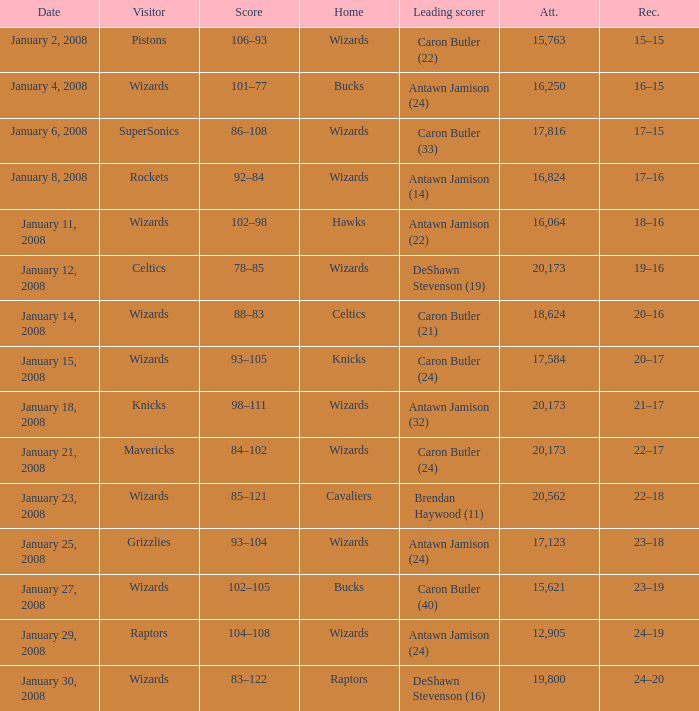Would you be able to parse every entry in this table? {'header': ['Date', 'Visitor', 'Score', 'Home', 'Leading scorer', 'Att.', 'Rec.'], 'rows': [['January 2, 2008', 'Pistons', '106–93', 'Wizards', 'Caron Butler (22)', '15,763', '15–15'], ['January 4, 2008', 'Wizards', '101–77', 'Bucks', 'Antawn Jamison (24)', '16,250', '16–15'], ['January 6, 2008', 'SuperSonics', '86–108', 'Wizards', 'Caron Butler (33)', '17,816', '17–15'], ['January 8, 2008', 'Rockets', '92–84', 'Wizards', 'Antawn Jamison (14)', '16,824', '17–16'], ['January 11, 2008', 'Wizards', '102–98', 'Hawks', 'Antawn Jamison (22)', '16,064', '18–16'], ['January 12, 2008', 'Celtics', '78–85', 'Wizards', 'DeShawn Stevenson (19)', '20,173', '19–16'], ['January 14, 2008', 'Wizards', '88–83', 'Celtics', 'Caron Butler (21)', '18,624', '20–16'], ['January 15, 2008', 'Wizards', '93–105', 'Knicks', 'Caron Butler (24)', '17,584', '20–17'], ['January 18, 2008', 'Knicks', '98–111', 'Wizards', 'Antawn Jamison (32)', '20,173', '21–17'], ['January 21, 2008', 'Mavericks', '84–102', 'Wizards', 'Caron Butler (24)', '20,173', '22–17'], ['January 23, 2008', 'Wizards', '85–121', 'Cavaliers', 'Brendan Haywood (11)', '20,562', '22–18'], ['January 25, 2008', 'Grizzlies', '93–104', 'Wizards', 'Antawn Jamison (24)', '17,123', '23–18'], ['January 27, 2008', 'Wizards', '102–105', 'Bucks', 'Caron Butler (40)', '15,621', '23–19'], ['January 29, 2008', 'Raptors', '104–108', 'Wizards', 'Antawn Jamison (24)', '12,905', '24–19'], ['January 30, 2008', 'Wizards', '83–122', 'Raptors', 'DeShawn Stevenson (16)', '19,800', '24–20']]} What is the record when the leading scorer is Antawn Jamison (14)? 17–16. 